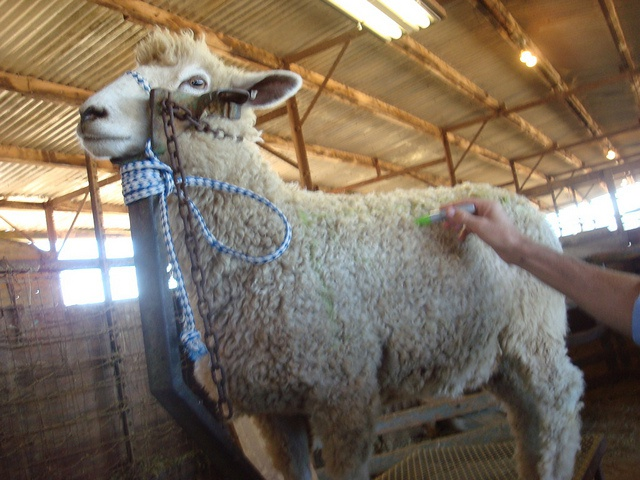Describe the objects in this image and their specific colors. I can see sheep in tan, gray, darkgray, and black tones and people in tan, gray, darkgray, and maroon tones in this image. 